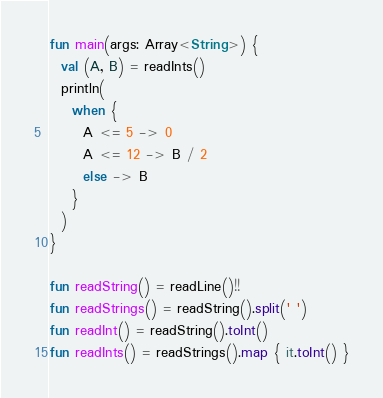Convert code to text. <code><loc_0><loc_0><loc_500><loc_500><_Kotlin_>fun main(args: Array<String>) {
  val (A, B) = readInts()
  println(
    when {
      A <= 5 -> 0
      A <= 12 -> B / 2
      else -> B
    }
  )
}

fun readString() = readLine()!!
fun readStrings() = readString().split(' ')
fun readInt() = readString().toInt()
fun readInts() = readStrings().map { it.toInt() }
</code> 